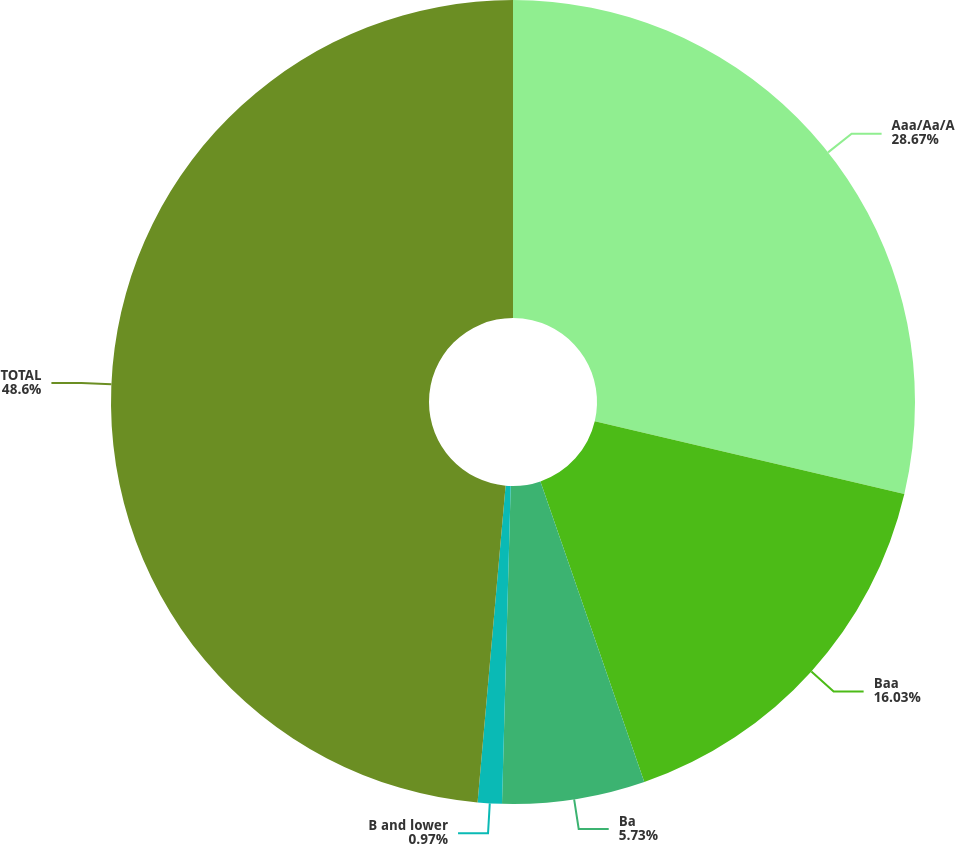<chart> <loc_0><loc_0><loc_500><loc_500><pie_chart><fcel>Aaa/Aa/A<fcel>Baa<fcel>Ba<fcel>B and lower<fcel>TOTAL<nl><fcel>28.67%<fcel>16.03%<fcel>5.73%<fcel>0.97%<fcel>48.59%<nl></chart> 